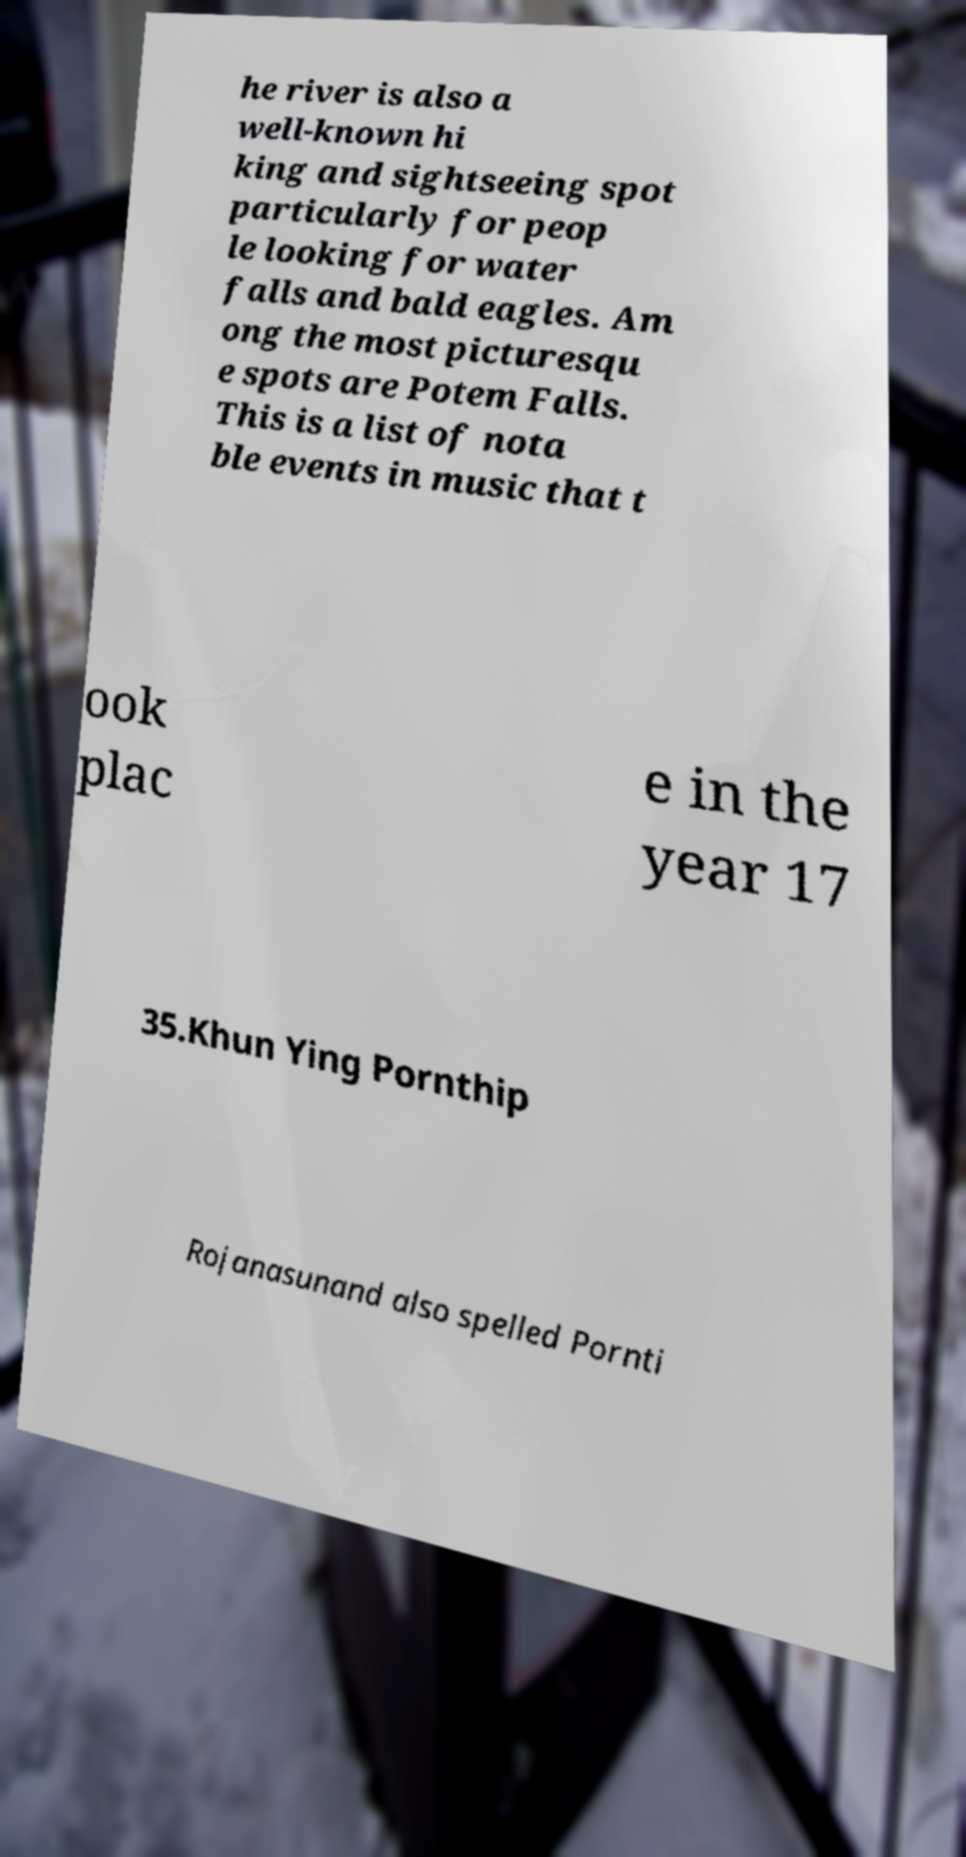For documentation purposes, I need the text within this image transcribed. Could you provide that? he river is also a well-known hi king and sightseeing spot particularly for peop le looking for water falls and bald eagles. Am ong the most picturesqu e spots are Potem Falls. This is a list of nota ble events in music that t ook plac e in the year 17 35.Khun Ying Pornthip Rojanasunand also spelled Pornti 